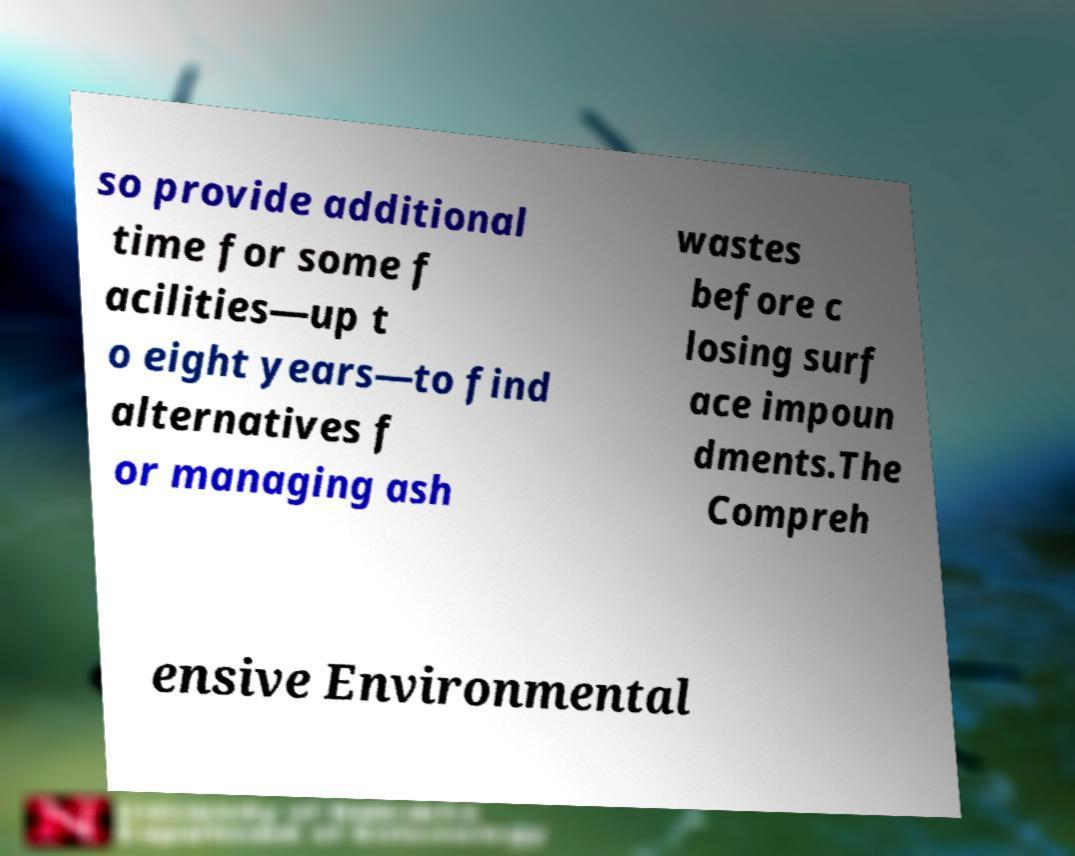I need the written content from this picture converted into text. Can you do that? so provide additional time for some f acilities—up t o eight years—to find alternatives f or managing ash wastes before c losing surf ace impoun dments.The Compreh ensive Environmental 